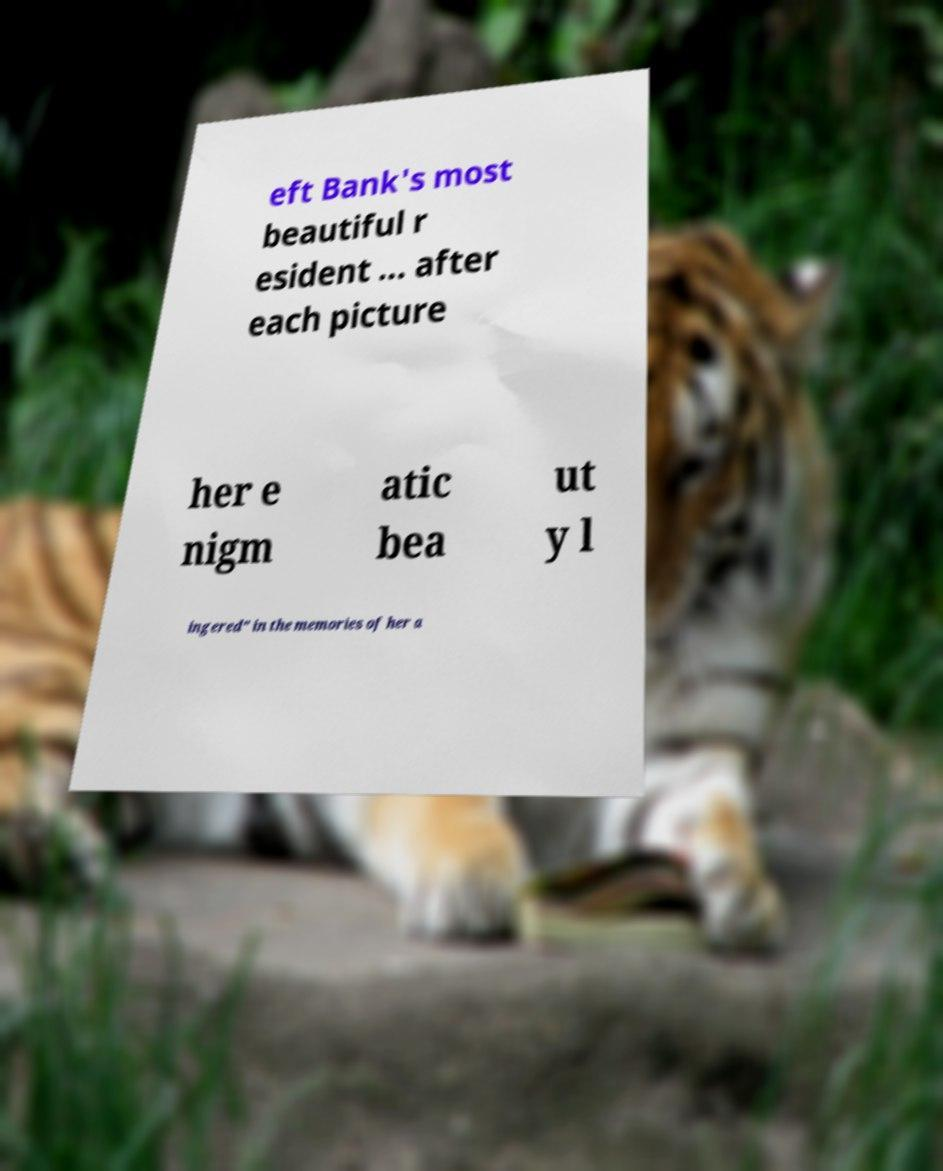Please identify and transcribe the text found in this image. eft Bank's most beautiful r esident ... after each picture her e nigm atic bea ut y l ingered" in the memories of her a 